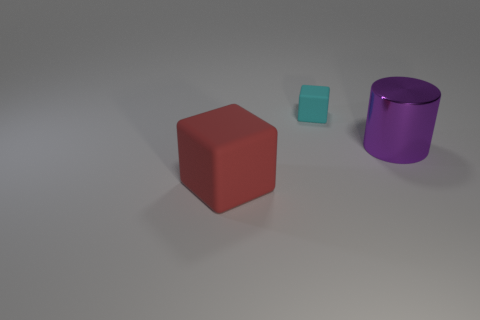There is a object that is left of the metallic cylinder and in front of the small cyan matte object; what shape is it?
Ensure brevity in your answer.  Cube. Is the thing that is behind the large metallic cylinder made of the same material as the cylinder?
Your answer should be very brief. No. Is there anything else that has the same material as the large purple cylinder?
Provide a short and direct response. No. The other object that is the same size as the purple object is what color?
Your answer should be compact. Red. There is a object that is the same material as the large block; what size is it?
Ensure brevity in your answer.  Small. How many other things are there of the same size as the red matte block?
Provide a short and direct response. 1. There is a block in front of the tiny cyan matte block; what is it made of?
Provide a succinct answer. Rubber. There is a rubber thing that is to the left of the cube behind the thing that is in front of the purple metal object; what shape is it?
Offer a very short reply. Cube. Is the size of the red rubber cube the same as the purple object?
Provide a succinct answer. Yes. How many objects are either small gray metal cylinders or blocks in front of the tiny object?
Provide a short and direct response. 1. 